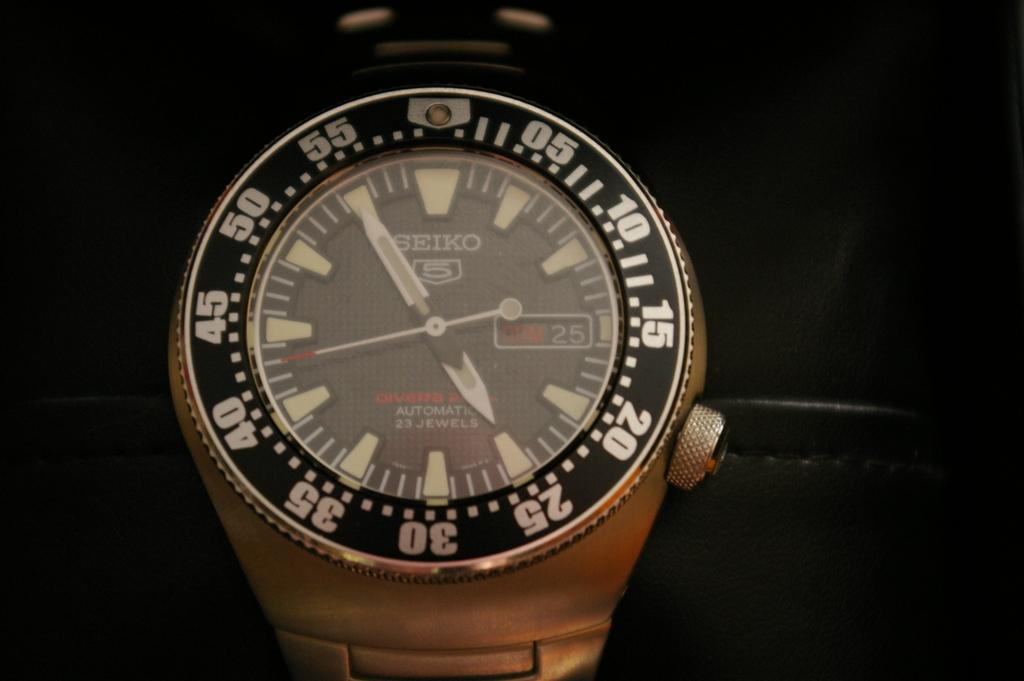<image>
Write a terse but informative summary of the picture. A Seiko watch shows the day of the month as being 25. 